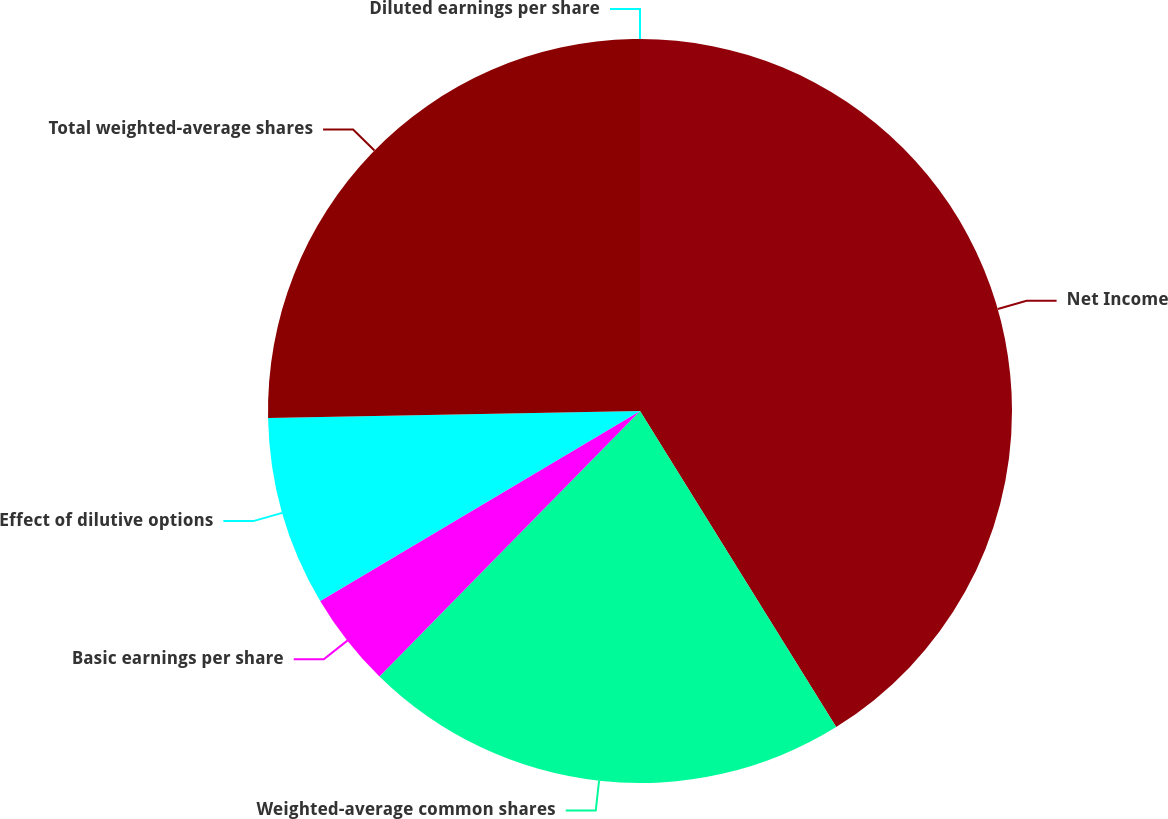Convert chart. <chart><loc_0><loc_0><loc_500><loc_500><pie_chart><fcel>Net Income<fcel>Weighted-average common shares<fcel>Basic earnings per share<fcel>Effect of dilutive options<fcel>Total weighted-average shares<fcel>Diluted earnings per share<nl><fcel>41.16%<fcel>21.19%<fcel>4.12%<fcel>8.23%<fcel>25.3%<fcel>0.0%<nl></chart> 